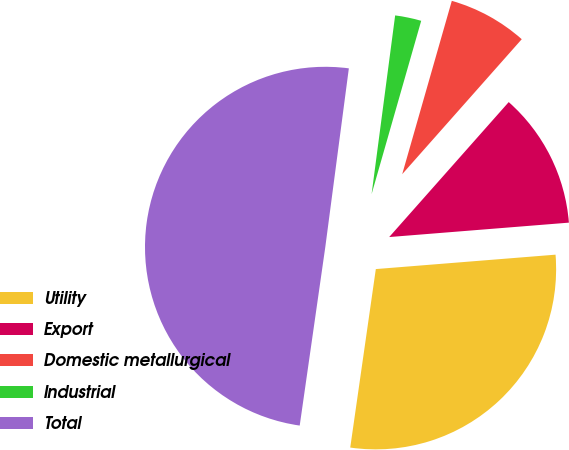<chart> <loc_0><loc_0><loc_500><loc_500><pie_chart><fcel>Utility<fcel>Export<fcel>Domestic metallurgical<fcel>Industrial<fcel>Total<nl><fcel>28.54%<fcel>12.19%<fcel>7.1%<fcel>2.35%<fcel>49.82%<nl></chart> 